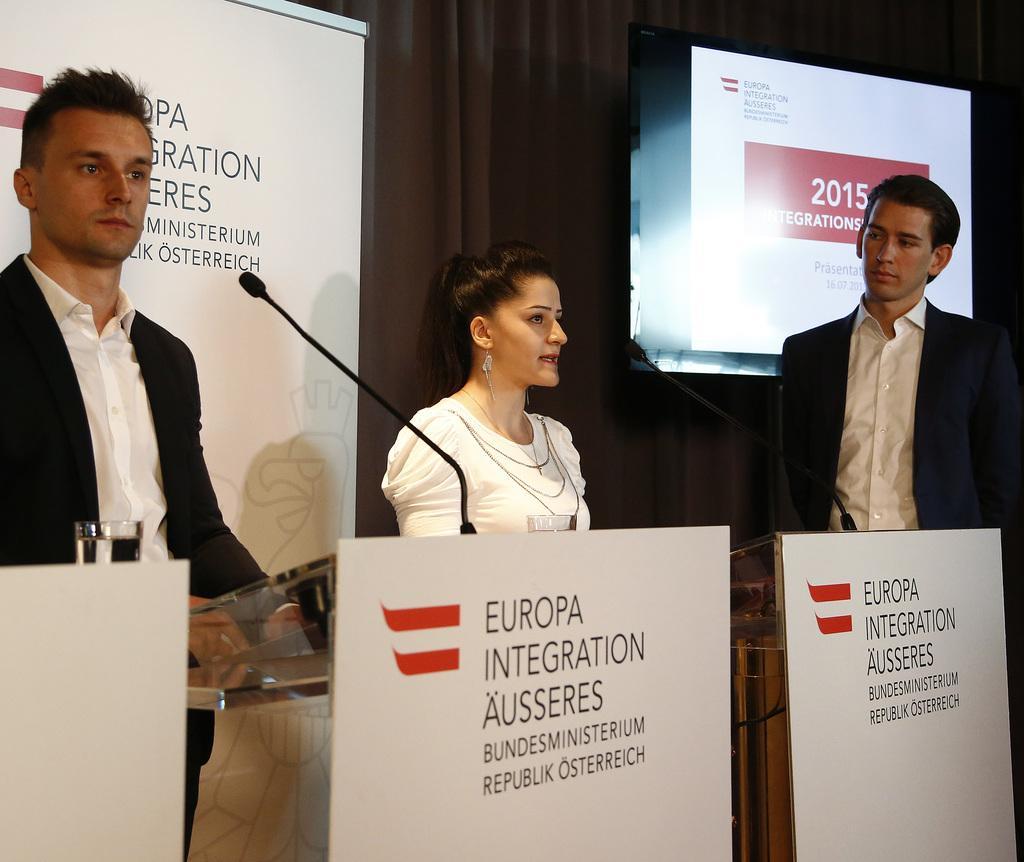In one or two sentences, can you explain what this image depicts? In this picture there are two persons standing behind the podium and there is a person standing at the right side of the image. There are microphones and there is a glass and there are boards on the podium. At the back there is a hoarding and there is a screen and curtain. 